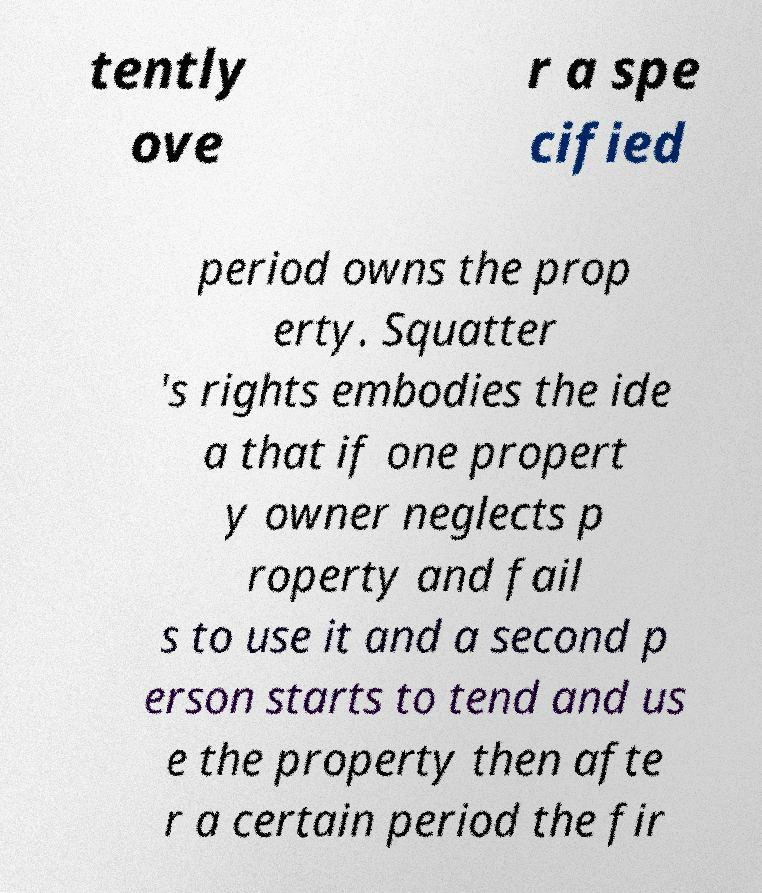Please identify and transcribe the text found in this image. tently ove r a spe cified period owns the prop erty. Squatter 's rights embodies the ide a that if one propert y owner neglects p roperty and fail s to use it and a second p erson starts to tend and us e the property then afte r a certain period the fir 